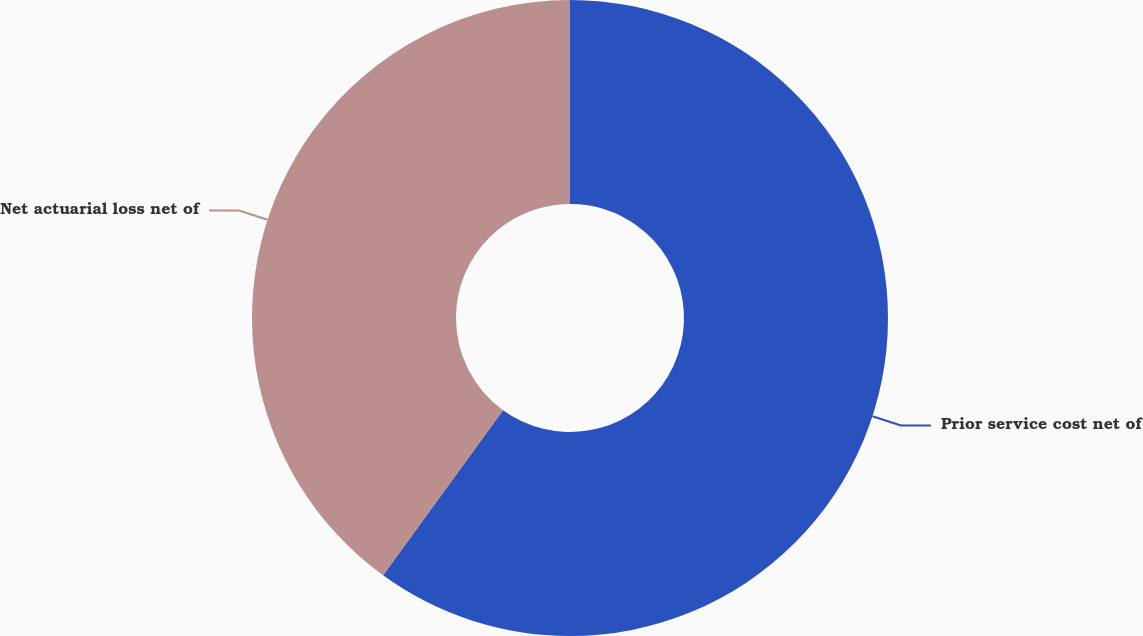Convert chart to OTSL. <chart><loc_0><loc_0><loc_500><loc_500><pie_chart><fcel>Prior service cost net of<fcel>Net actuarial loss net of<nl><fcel>60.0%<fcel>40.0%<nl></chart> 